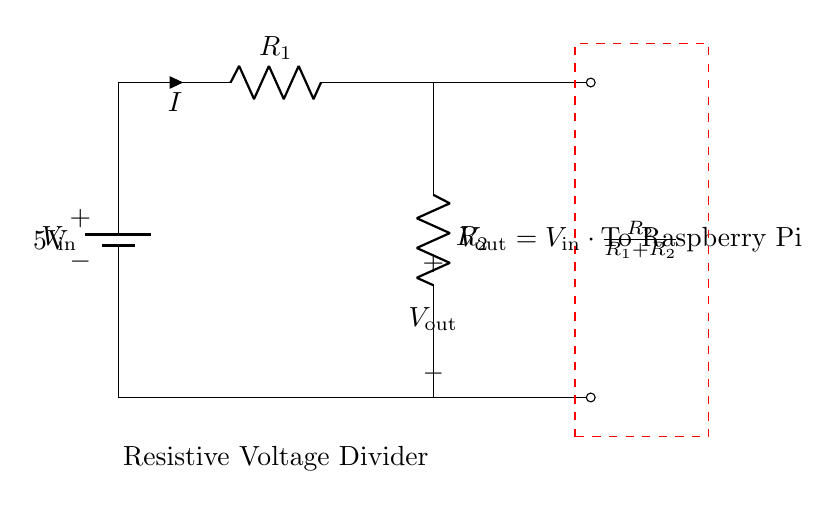What is the input voltage of this circuit? The input voltage, denoted as V_in, is labeled on the battery component in the diagram, which indicates a value of 5 volts.
Answer: 5 volts What are the values of the resistors in this circuit? The resistor values R_1 and R_2 are not specified in the diagram, but they are labeled as R_1 and R_2. The exact values would need to be defined separately for calculations.
Answer: R_1 and R_2 What is the output voltage formula for this divider? The output voltage V_out is expressed as a formula that combines the input voltage V_in and the resistors, shown as V_out = V_in * (R_2 / (R_1 + R_2)), indicating how output voltage depends on resistor values.
Answer: V_out = V_in * (R_2 / (R_1 + R_2)) What happens to the output voltage if R_2 is increased? Increasing R_2 will increase the output voltage V_out since, according to the voltage divider formula, a larger R_2 relative to R_1 increases the ratio, thus raising V_out.
Answer: Increases What is the purpose of the dashed rectangle in the diagram? The dashed rectangle visually indicates the section of the circuit that is specifically connected to the Raspberry Pi, highlighting the area where the output voltage is delivered.
Answer: To isolate the Raspberry Pi section What is the current labeled in the circuit? The current flowing through the circuit is labeled with the symbol 'I', which is indicated next to resistor R_1, showing the direction and flow of current through this part of the circuit.
Answer: I 